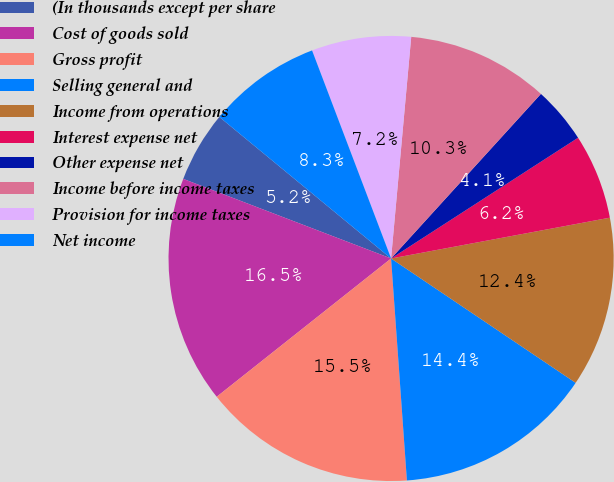Convert chart to OTSL. <chart><loc_0><loc_0><loc_500><loc_500><pie_chart><fcel>(In thousands except per share<fcel>Cost of goods sold<fcel>Gross profit<fcel>Selling general and<fcel>Income from operations<fcel>Interest expense net<fcel>Other expense net<fcel>Income before income taxes<fcel>Provision for income taxes<fcel>Net income<nl><fcel>5.15%<fcel>16.49%<fcel>15.46%<fcel>14.43%<fcel>12.37%<fcel>6.19%<fcel>4.12%<fcel>10.31%<fcel>7.22%<fcel>8.25%<nl></chart> 